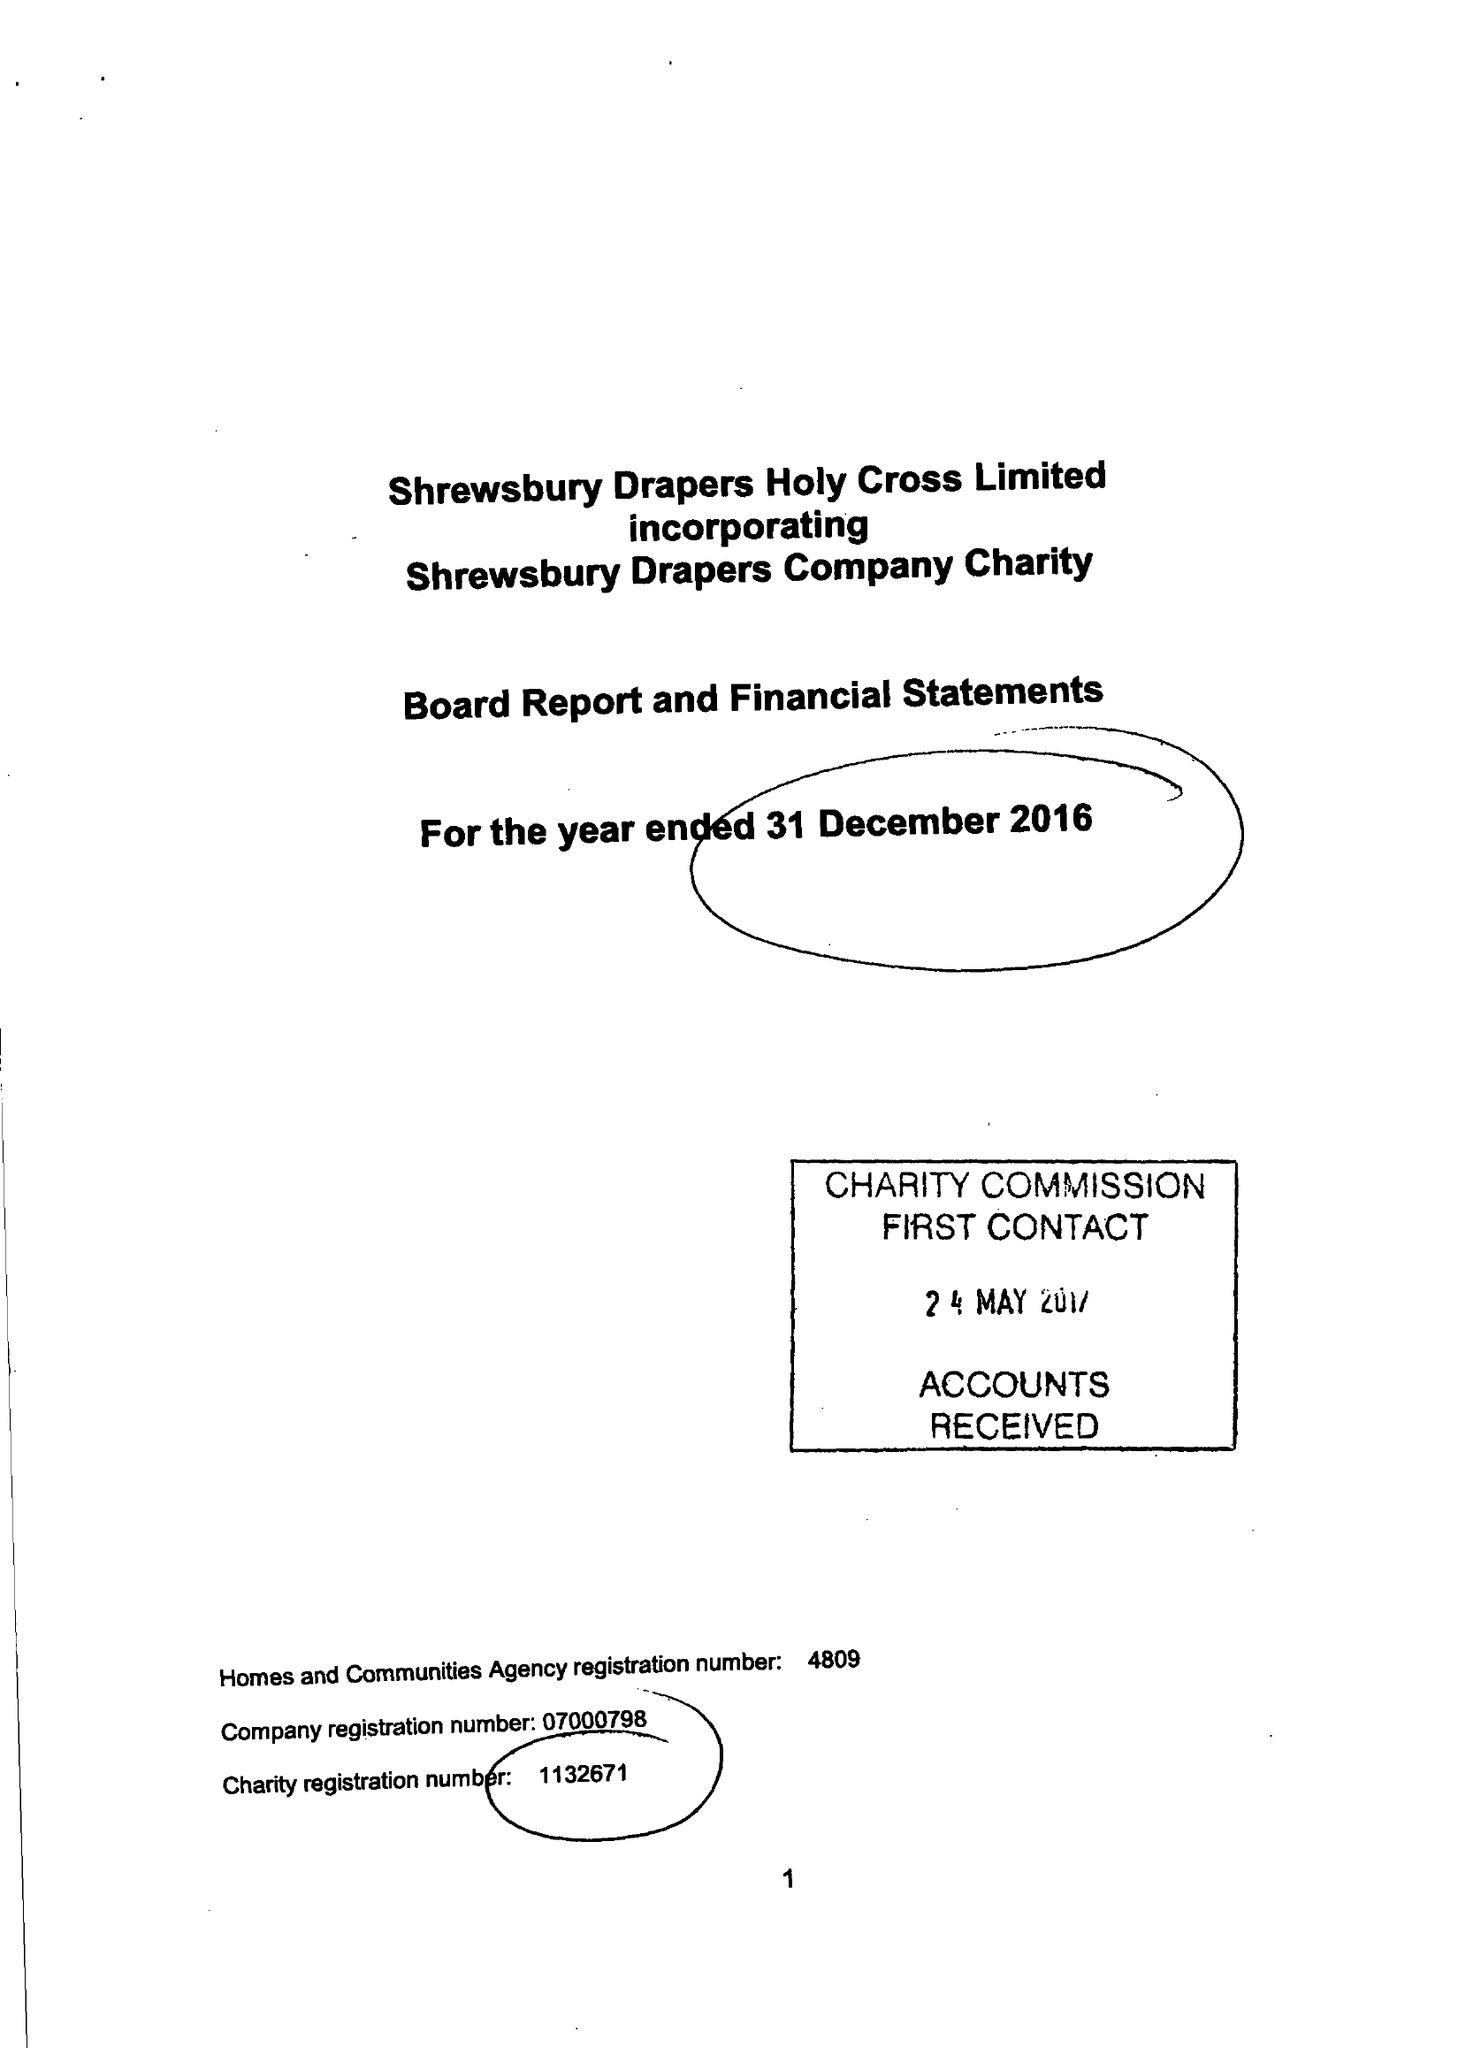What is the value for the address__postcode?
Answer the question using a single word or phrase. SY2 6BP 